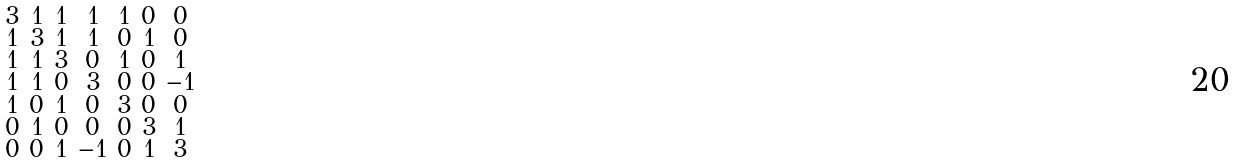<formula> <loc_0><loc_0><loc_500><loc_500>\begin{smallmatrix} 3 & 1 & 1 & 1 & 1 & 0 & 0 \\ 1 & 3 & 1 & 1 & 0 & 1 & 0 \\ 1 & 1 & 3 & 0 & 1 & 0 & 1 \\ 1 & 1 & 0 & 3 & 0 & 0 & - 1 \\ 1 & 0 & 1 & 0 & 3 & 0 & 0 \\ 0 & 1 & 0 & 0 & 0 & 3 & 1 \\ 0 & 0 & 1 & - 1 & 0 & 1 & 3 \end{smallmatrix}</formula> 